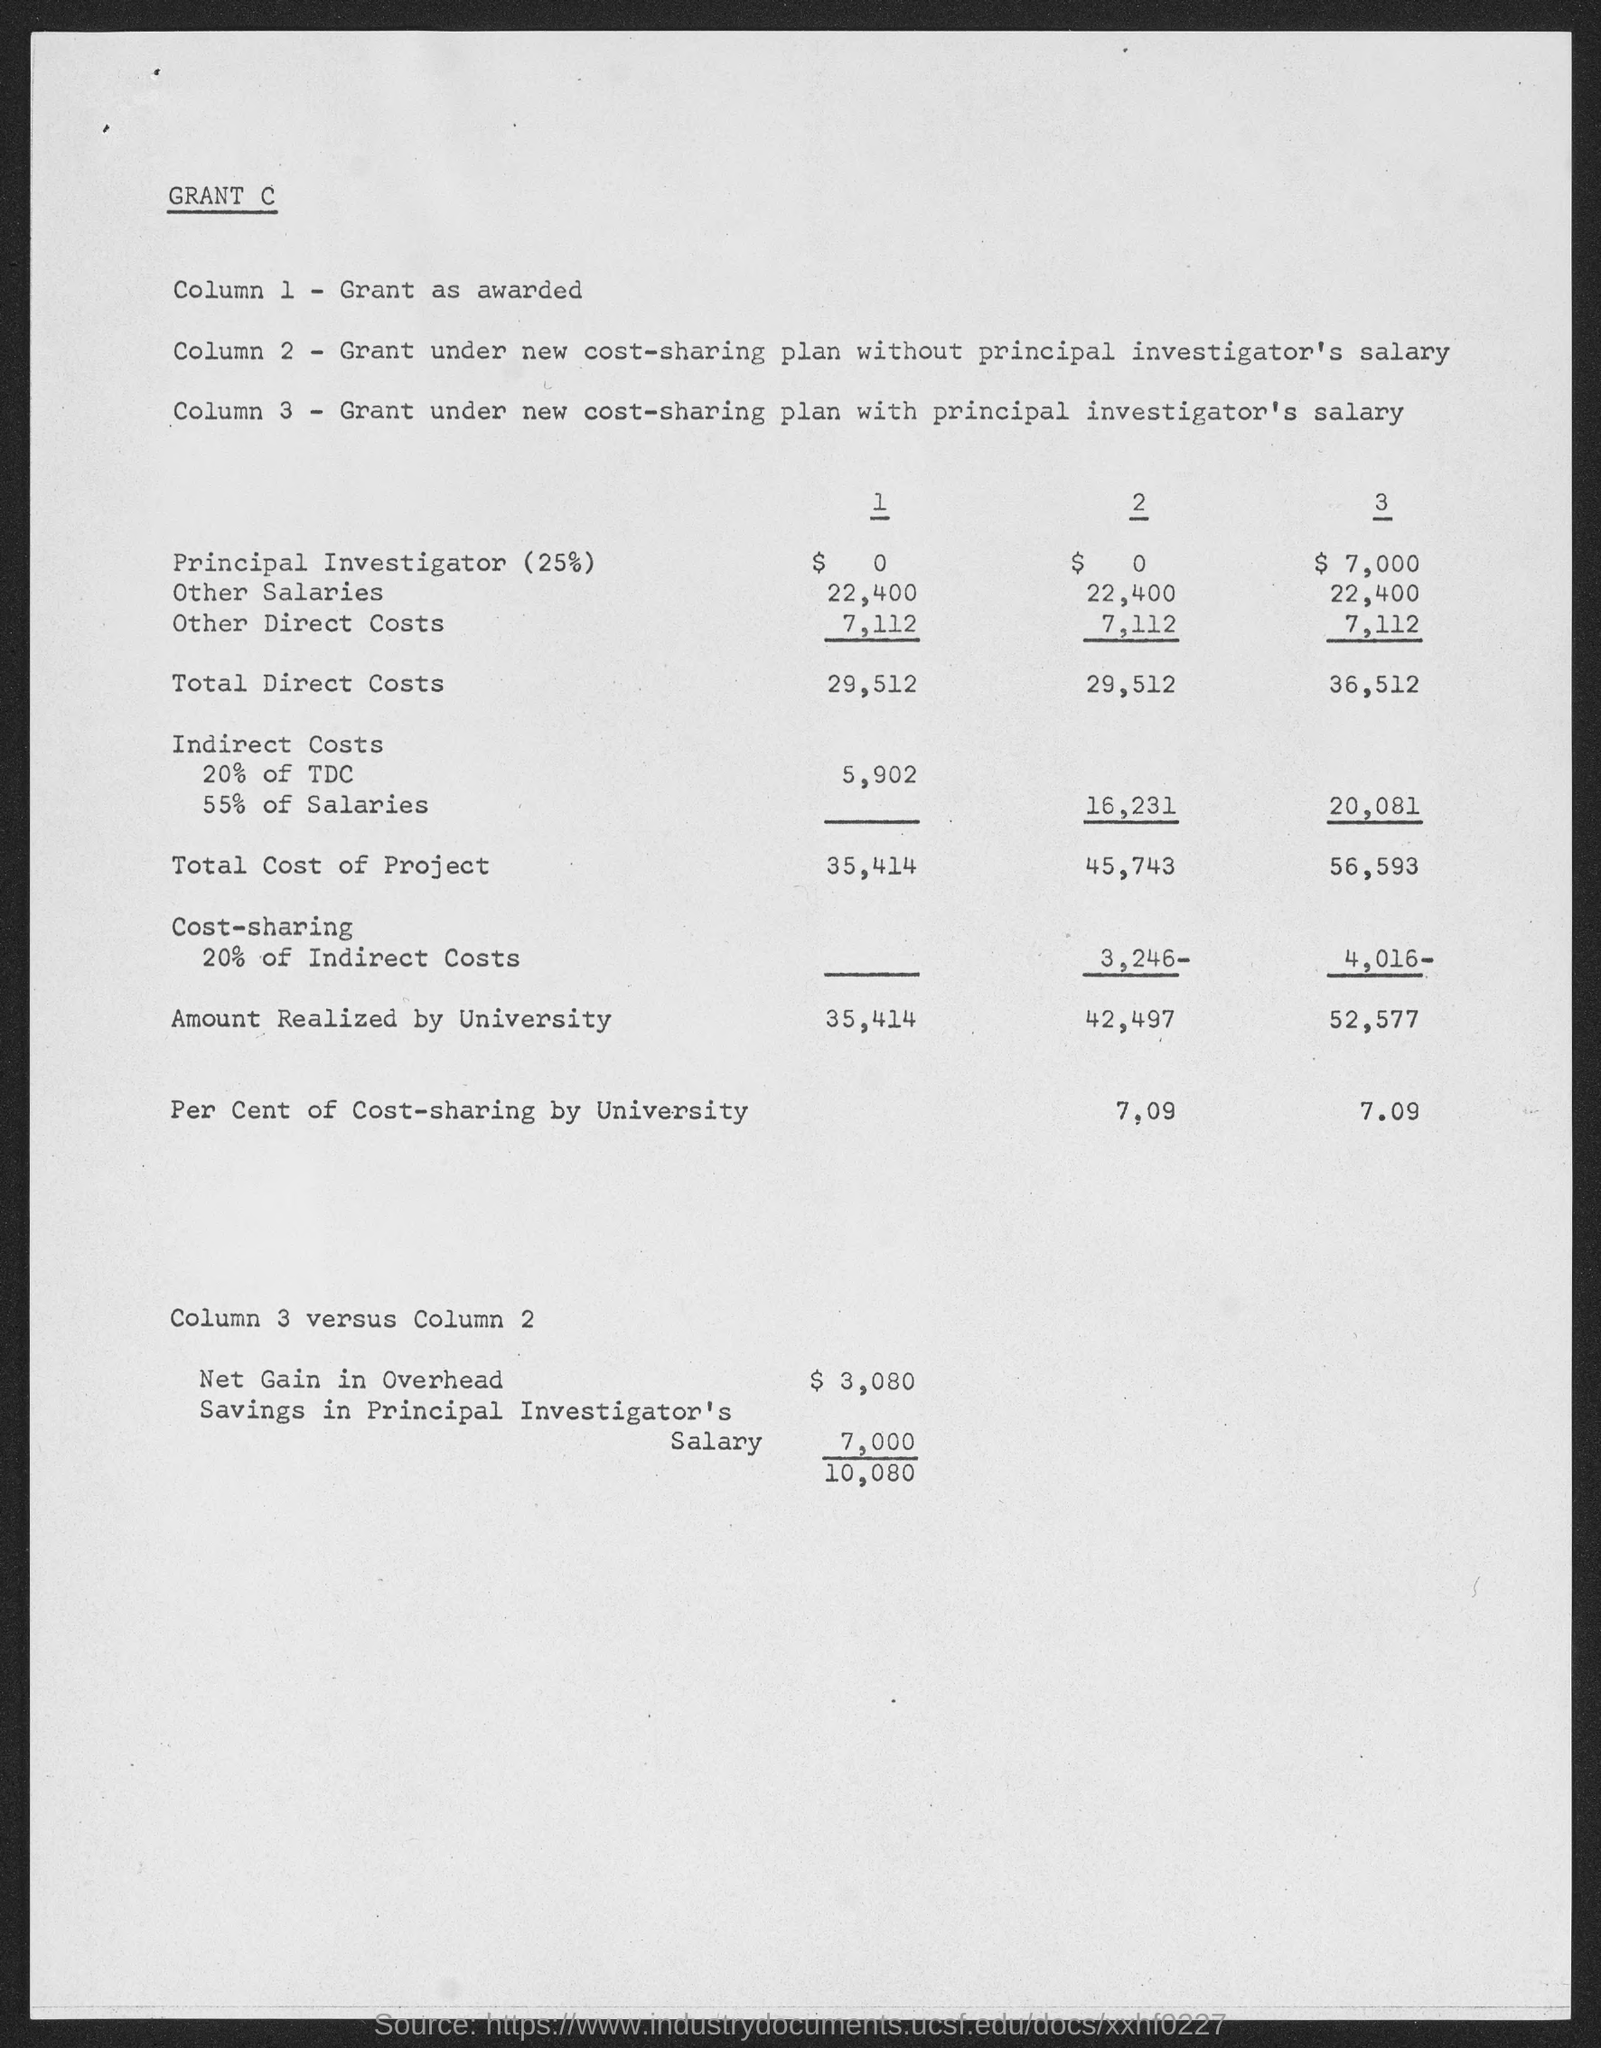What is Column 1?
Your answer should be compact. Grant as awarded. 